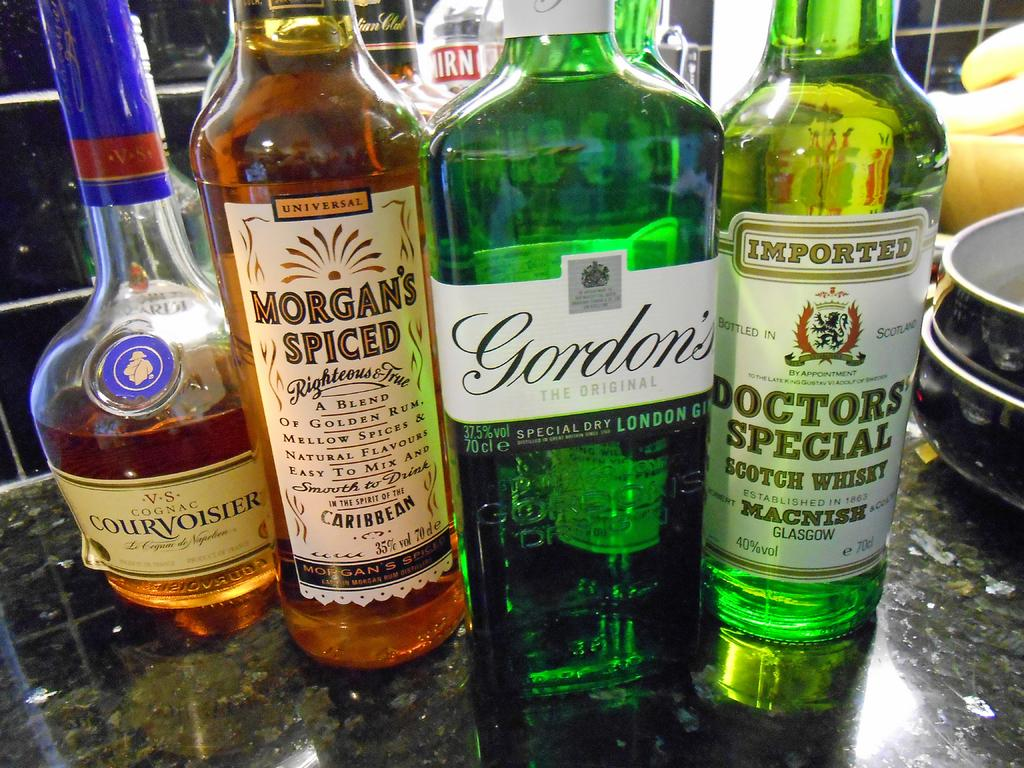<image>
Create a compact narrative representing the image presented. Various bottles of liquor are arranged on a counter including Doctors Special Scotch Whisky. 